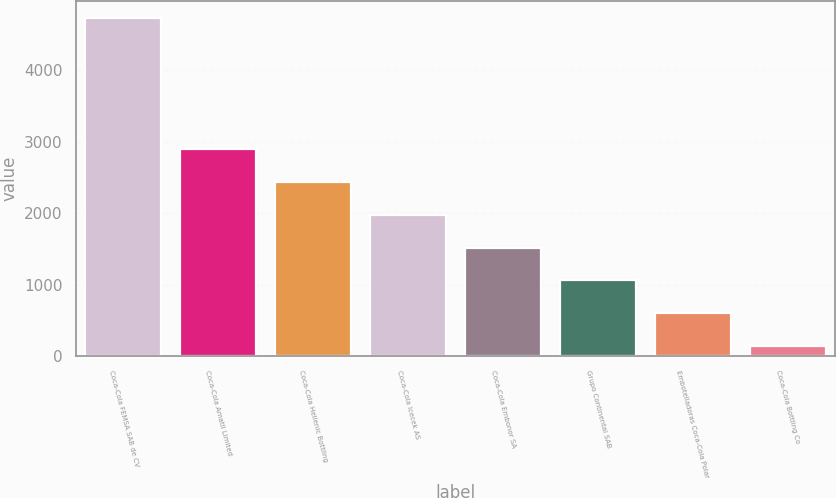Convert chart to OTSL. <chart><loc_0><loc_0><loc_500><loc_500><bar_chart><fcel>Coca-Cola FEMSA SAB de CV<fcel>Coca-Cola Amatil Limited<fcel>Coca-Cola Hellenic Bottling<fcel>Coca-Cola Icecek AS<fcel>Coca-Cola Embonor SA<fcel>Grupo Continental SAB<fcel>Embotelladoras Coca-Cola Polar<fcel>Coca-Cola Bottling Co<nl><fcel>4740<fcel>2899.2<fcel>2439<fcel>1978.8<fcel>1518.6<fcel>1058.4<fcel>598.2<fcel>138<nl></chart> 